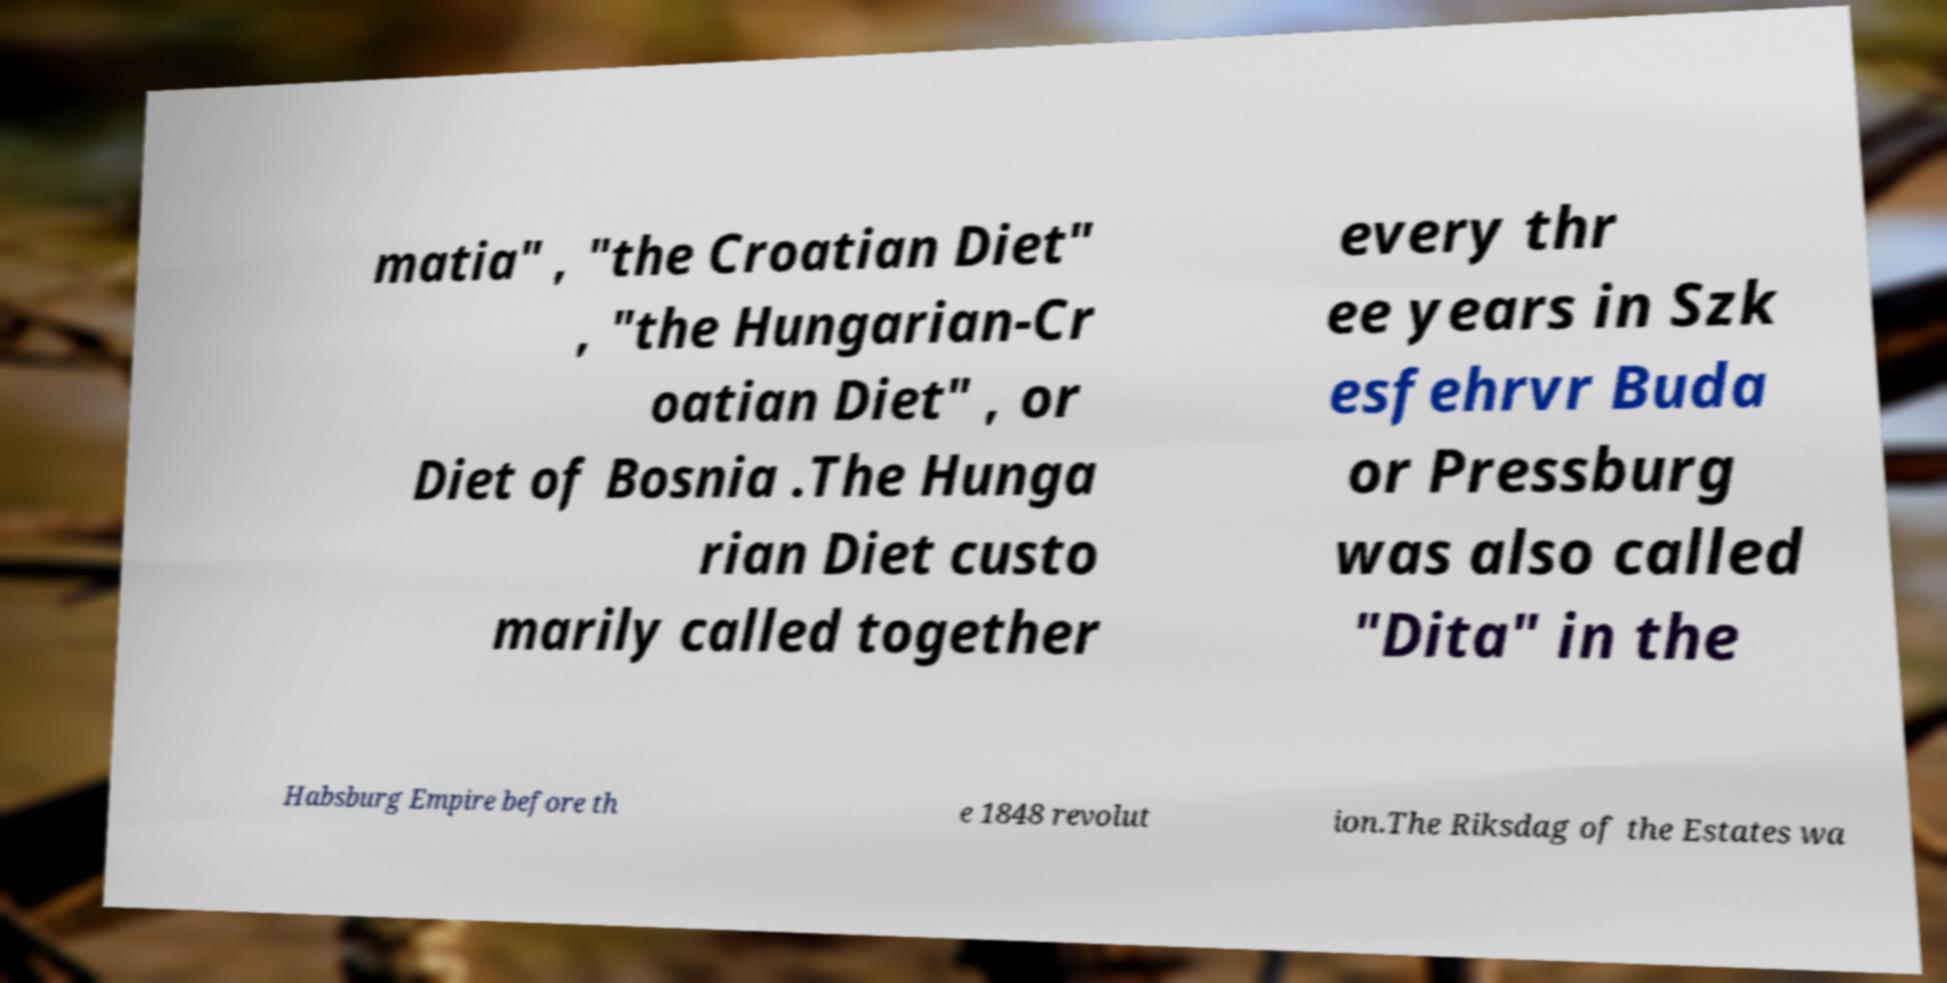Can you read and provide the text displayed in the image?This photo seems to have some interesting text. Can you extract and type it out for me? matia" , "the Croatian Diet" , "the Hungarian-Cr oatian Diet" , or Diet of Bosnia .The Hunga rian Diet custo marily called together every thr ee years in Szk esfehrvr Buda or Pressburg was also called "Dita" in the Habsburg Empire before th e 1848 revolut ion.The Riksdag of the Estates wa 